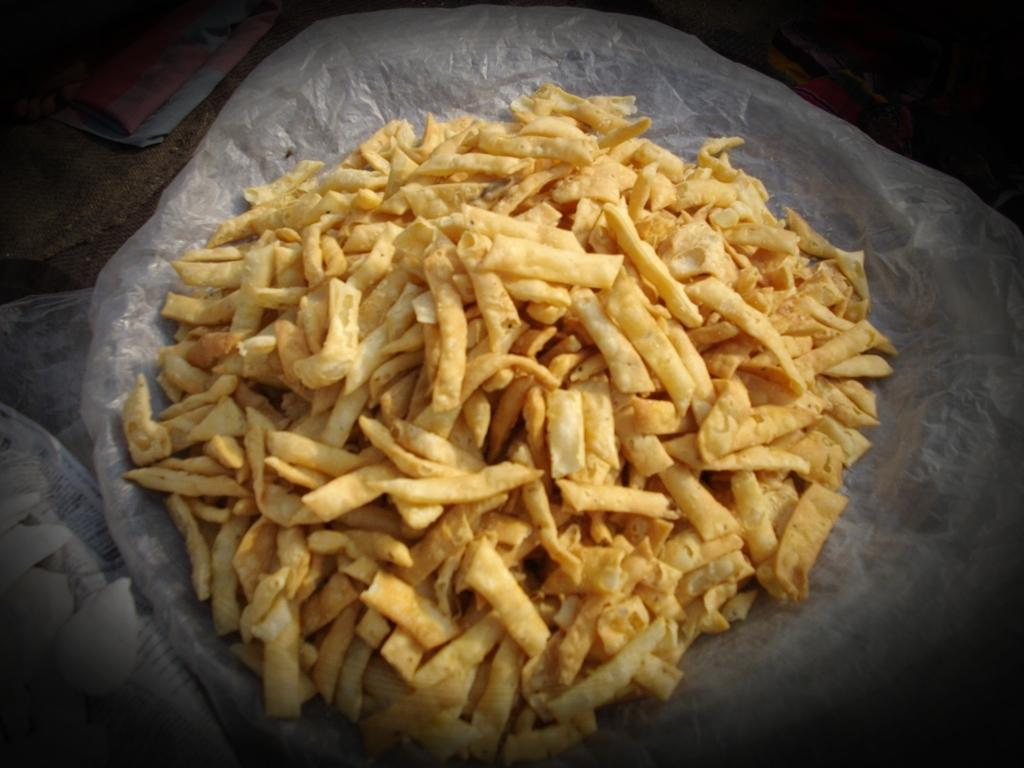What type of food items can be seen in the image? There are snacks in the image. How are the snacks stored or contained? The snacks are in a brown-colored plastic container. What type of coal is present in the image? There is no coal present in the image; it features snacks in a brown-colored plastic container. 